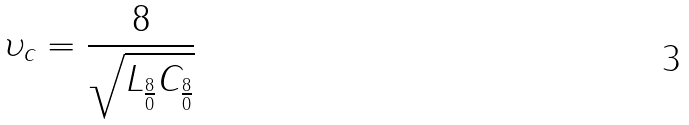Convert formula to latex. <formula><loc_0><loc_0><loc_500><loc_500>\upsilon _ { c } = \frac { 8 } { \sqrt { L _ { \frac { 8 } { 0 } } C _ { \frac { 8 } { 0 } } } }</formula> 